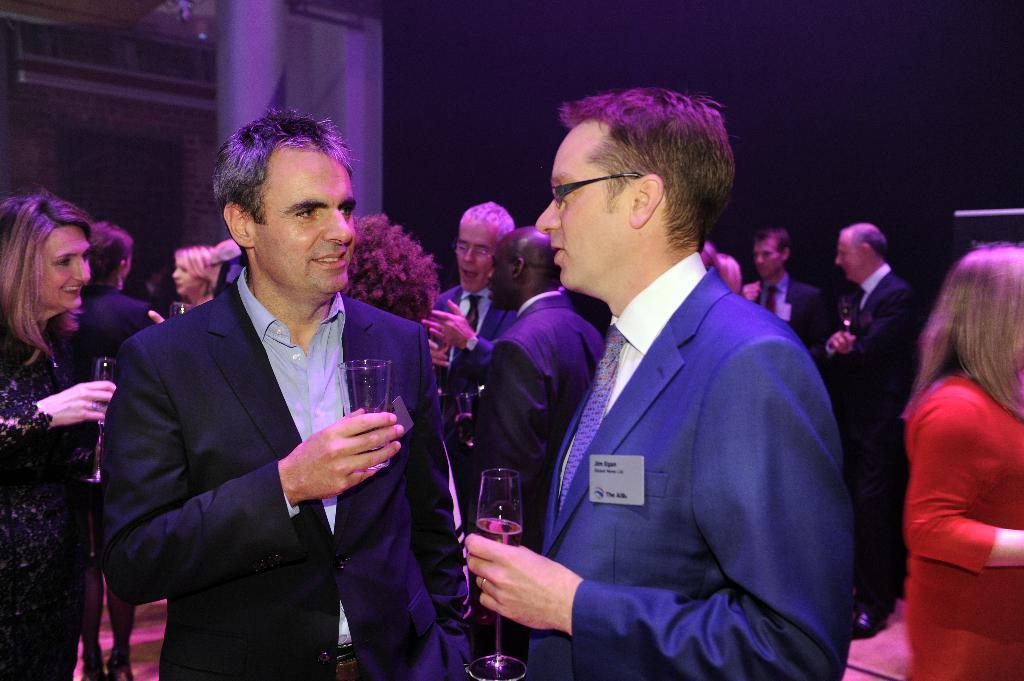Can you describe this image briefly? In this picture I can see few people are standing and few of them holding glasses in their hands. 